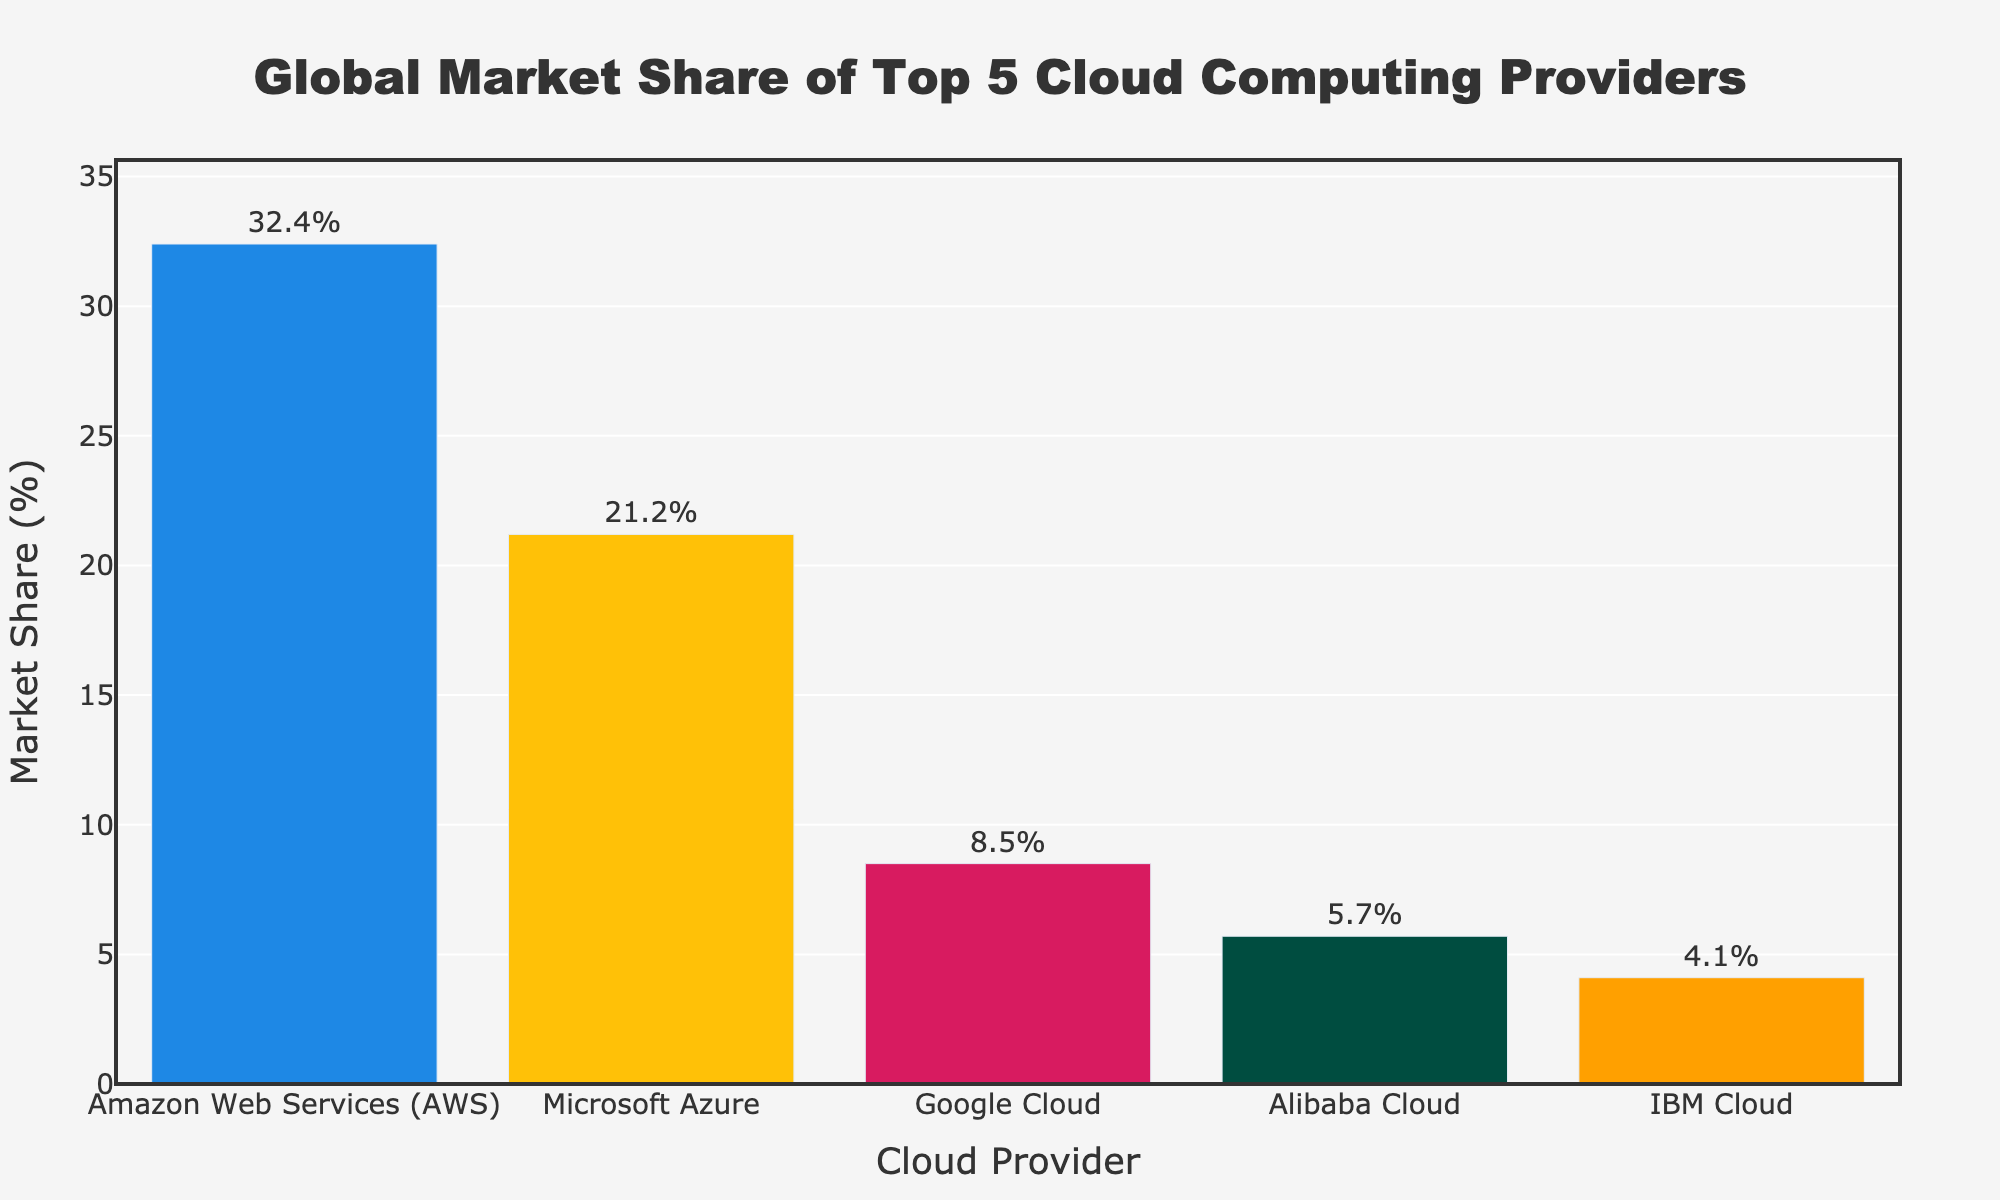What's the market share of Amazon Web Services (AWS)? The figure shows a bar for Amazon Web Services (AWS) labeled with its market share. By looking at this bar, we see the value next to it.
Answer: 32.4% Which cloud provider ranks second in market share? To determine the second in ranking, we compare the heights of the bars and their labeled percentages. Microsoft Azure has the second-largest bar with a market share of 21.2%.
Answer: Microsoft Azure What is the total market share of the top 3 cloud providers? We need to add the market shares of the top three providers: Amazon Web Services (32.4%), Microsoft Azure (21.2%), and Google Cloud (8.5%). The calculation is 32.4% + 21.2% + 8.5% = 62.1%.
Answer: 62.1% How much greater is AWS's market share compared to IBM Cloud's? We subtract IBM Cloud's market share (4.1%) from AWS's market share (32.4%). The calculation is 32.4% - 4.1% = 28.3%.
Answer: 28.3% Do any cloud providers have a market share less than 6%? We look at the bars and their labeled values. Both Alibaba Cloud and IBM Cloud are below 6%, with 5.7% and 4.1%, respectively.
Answer: Yes What is the average market share of the providers listed? To find the average, we sum the market shares of all five providers and divide by the number of providers. The sum is 32.4% + 21.2% + 8.5% + 5.7% + 4.1% = 71.9%. Dividing by 5 gives 71.9% / 5 = 14.38%.
Answer: 14.38% Which provider has approximately four times the market share of Google Cloud? We compare each provider's market share relative to Google Cloud's (8.5%). Amazon Web Services has 32.4%, which is approximately four times 8.5% (since 4 * 8.5% = 34%).
Answer: Amazon Web Services Which bar is colored blue, and what market share does it represent? By visually inspecting the figure, the only bar colored blue represents Amazon Web Services. The label next to it shows the market share is 32.4%.
Answer: Amazon Web Services, 32.4% Which provider has the smallest market share, and what is it? By comparing the heights of the bars and their labeled market shares, IBM Cloud has the smallest bar with a market share of 4.1%.
Answer: IBM Cloud, 4.1% How much do Alibaba Cloud and IBM Cloud contribute to the total market share together? We add the market shares of Alibaba Cloud (5.7%) and IBM Cloud (4.1%). The calculation is 5.7% + 4.1% = 9.8%.
Answer: 9.8% 